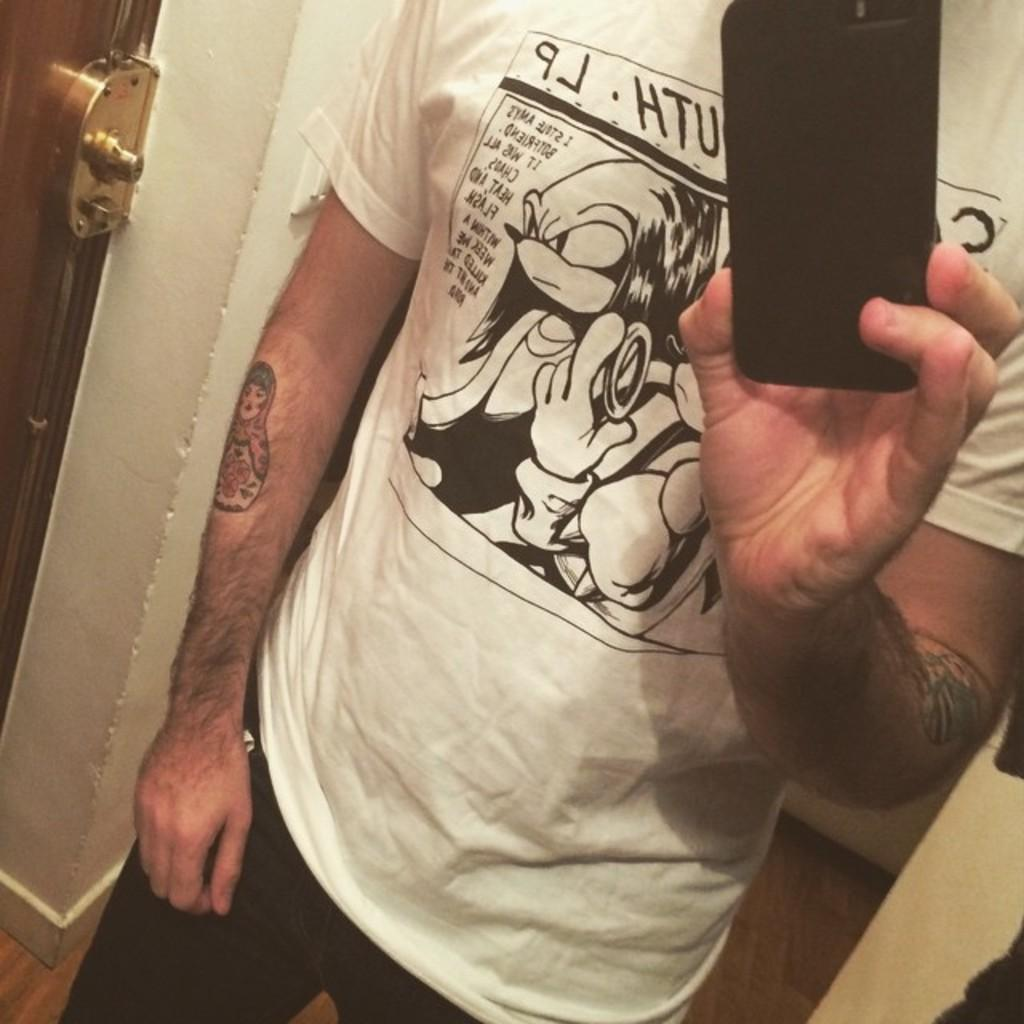Who is present in the image? There is a person in the image. What is the person wearing? The person is wearing a white t-shirt. What is the person holding in the image? The person is holding a mobile. What can be seen on the left side of the image? There is a door on the left side of the image. What is on the right side of the image? There is a wall on the right side of the image. Can you see the hand of the person petting the tramp in the image? There is no tramp present in the image, and therefore no hand petting it can be observed. 